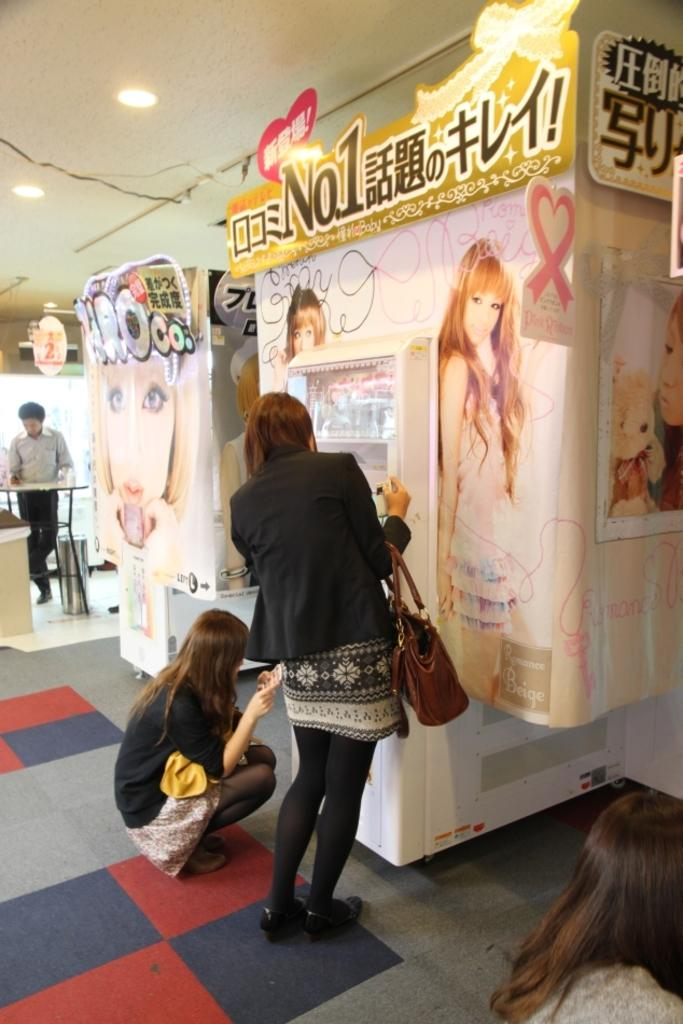How many people are in the image? There are three persons in the image. What is the surface they are standing on? The image shows a floor. What object can be seen in the image besides the people? There is a board and a table in the image. What can be seen providing illumination in the image? Lights are visible in the image. What type of amusement can be seen on the ground in the image? There is no amusement or ground present in the image. How does the image convey a sense of hate? The image does not convey any sense of hate; it simply shows three people, a board, a table, and lights. 